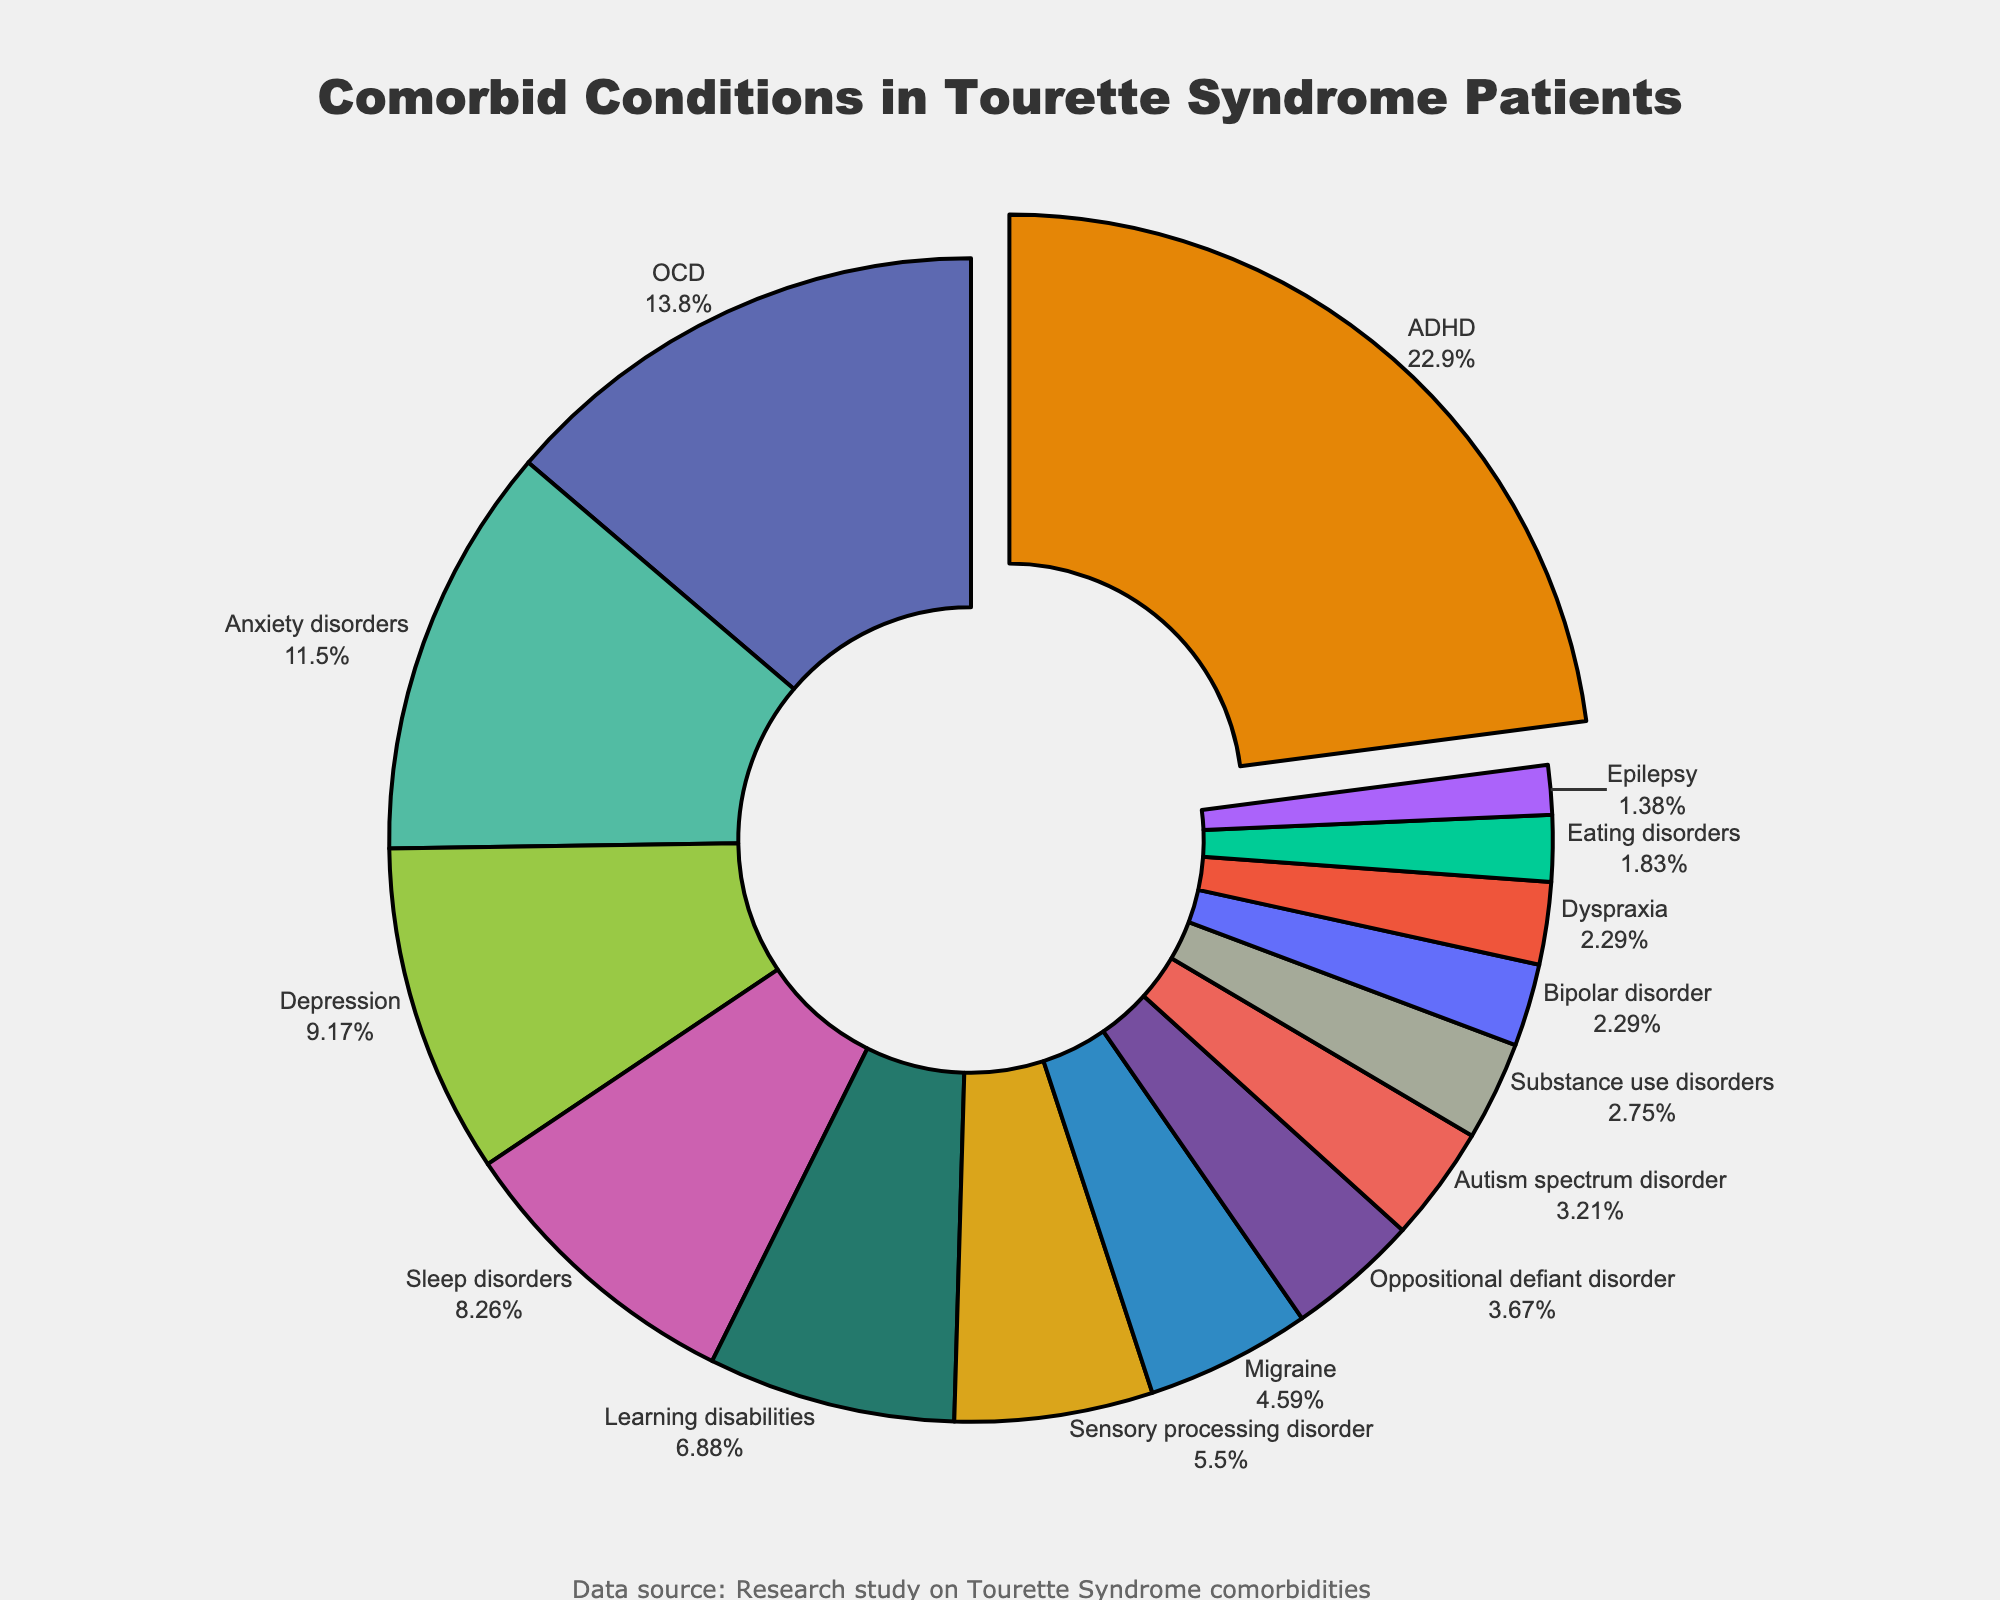Which comorbid condition has the highest percentage in Tourette Syndrome patients? Look for the condition that has the largest segment in the pie chart. The largest segment is pulled slightly out for emphasis.
Answer: ADHD Is the percentage of patients with Anxiety disorders higher or lower than those with Sensory processing disorder? Compare the segments labeled "Anxiety disorders" and "Sensory processing disorder". The one with a larger percentage is higher.
Answer: Higher What is the combined percentage of patients with Learning disabilities and Sleep disorders? Add the percentages of "Learning disabilities" and "Sleep disorders" together: 15% + 18% = 33%.
Answer: 33% Which comorbid condition has the lowest percentage, and what is that percentage? Look for the condition with the smallest segment in the pie chart.
Answer: Epilepsy, 3% How much higher is the percentage of patients with OCD compared to those with Autism spectrum disorder? Subtract the percentage of "Autism spectrum disorder" from "OCD": 30% - 7% = 23%.
Answer: 23% Are there more patients with Bipolar disorder or Substance use disorders? Compare the segments labeled "Bipolar disorder" and "Substance use disorders". The one with the larger percentage has more patients.
Answer: Substance use disorders What's the difference in percentage points between Depression and Migraine? Subtract the percentage of "Migraine" from "Depression": 20% - 10% = 10%.
Answer: 10% Which conditions together make up nearly one-third of the total population of patients? Look for conditions whose percentages add up to approximately 33%. Learning disabilities and Sleep disorders together make 33%.
Answer: Learning disabilities and Sleep disorders Is the combined percentage of ADHD and OCD more than half of the total? Add the percentages of "ADHD" and "OCD" together: 50% + 30% = 80%. Since 80% is more than 50%, the answer is yes.
Answer: Yes Which comorbid condition with a percentage less than 10% has the highest value and what is that percentage? Among conditions with less than 10%, identify the one with the highest percentage.
Answer: Migraine, 10% 